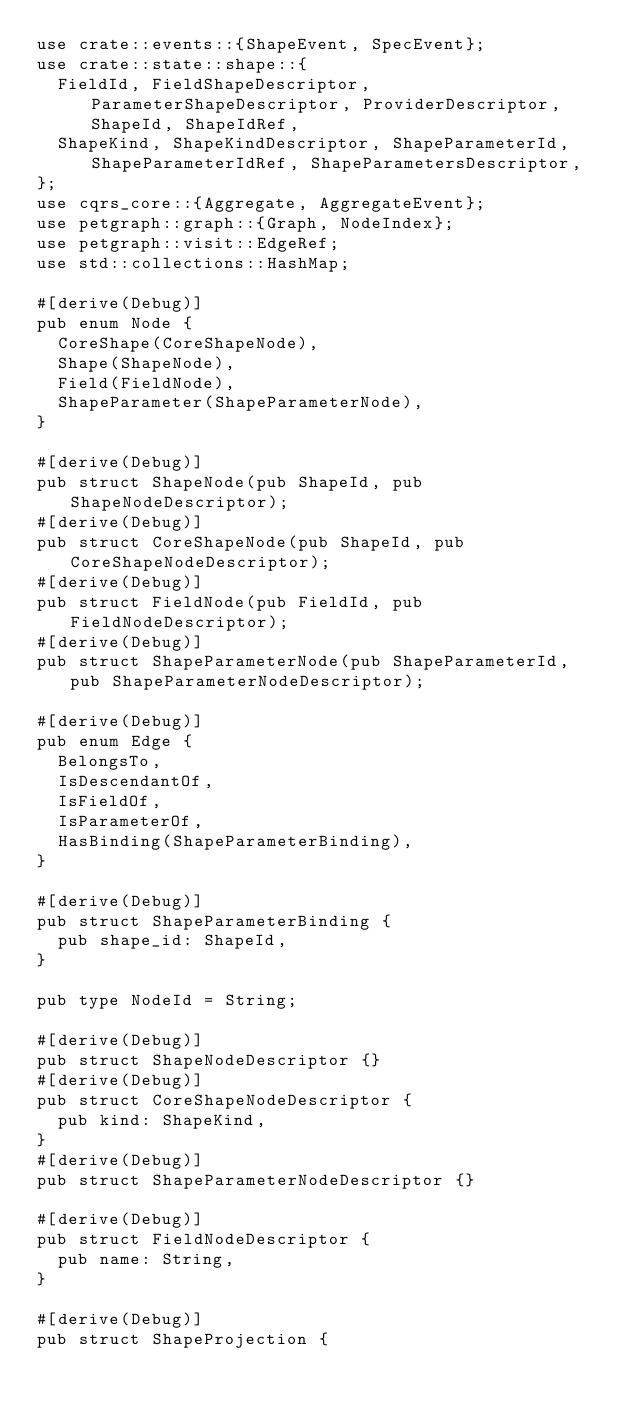Convert code to text. <code><loc_0><loc_0><loc_500><loc_500><_Rust_>use crate::events::{ShapeEvent, SpecEvent};
use crate::state::shape::{
  FieldId, FieldShapeDescriptor, ParameterShapeDescriptor, ProviderDescriptor, ShapeId, ShapeIdRef,
  ShapeKind, ShapeKindDescriptor, ShapeParameterId, ShapeParameterIdRef, ShapeParametersDescriptor,
};
use cqrs_core::{Aggregate, AggregateEvent};
use petgraph::graph::{Graph, NodeIndex};
use petgraph::visit::EdgeRef;
use std::collections::HashMap;

#[derive(Debug)]
pub enum Node {
  CoreShape(CoreShapeNode),
  Shape(ShapeNode),
  Field(FieldNode),
  ShapeParameter(ShapeParameterNode),
}

#[derive(Debug)]
pub struct ShapeNode(pub ShapeId, pub ShapeNodeDescriptor);
#[derive(Debug)]
pub struct CoreShapeNode(pub ShapeId, pub CoreShapeNodeDescriptor);
#[derive(Debug)]
pub struct FieldNode(pub FieldId, pub FieldNodeDescriptor);
#[derive(Debug)]
pub struct ShapeParameterNode(pub ShapeParameterId, pub ShapeParameterNodeDescriptor);

#[derive(Debug)]
pub enum Edge {
  BelongsTo,
  IsDescendantOf,
  IsFieldOf,
  IsParameterOf,
  HasBinding(ShapeParameterBinding),
}

#[derive(Debug)]
pub struct ShapeParameterBinding {
  pub shape_id: ShapeId,
}

pub type NodeId = String;

#[derive(Debug)]
pub struct ShapeNodeDescriptor {}
#[derive(Debug)]
pub struct CoreShapeNodeDescriptor {
  pub kind: ShapeKind,
}
#[derive(Debug)]
pub struct ShapeParameterNodeDescriptor {}

#[derive(Debug)]
pub struct FieldNodeDescriptor {
  pub name: String,
}

#[derive(Debug)]
pub struct ShapeProjection {</code> 